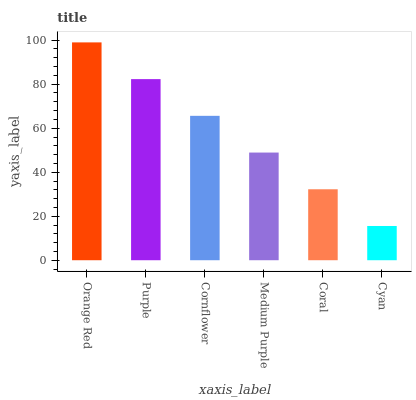Is Cyan the minimum?
Answer yes or no. Yes. Is Orange Red the maximum?
Answer yes or no. Yes. Is Purple the minimum?
Answer yes or no. No. Is Purple the maximum?
Answer yes or no. No. Is Orange Red greater than Purple?
Answer yes or no. Yes. Is Purple less than Orange Red?
Answer yes or no. Yes. Is Purple greater than Orange Red?
Answer yes or no. No. Is Orange Red less than Purple?
Answer yes or no. No. Is Cornflower the high median?
Answer yes or no. Yes. Is Medium Purple the low median?
Answer yes or no. Yes. Is Cyan the high median?
Answer yes or no. No. Is Purple the low median?
Answer yes or no. No. 